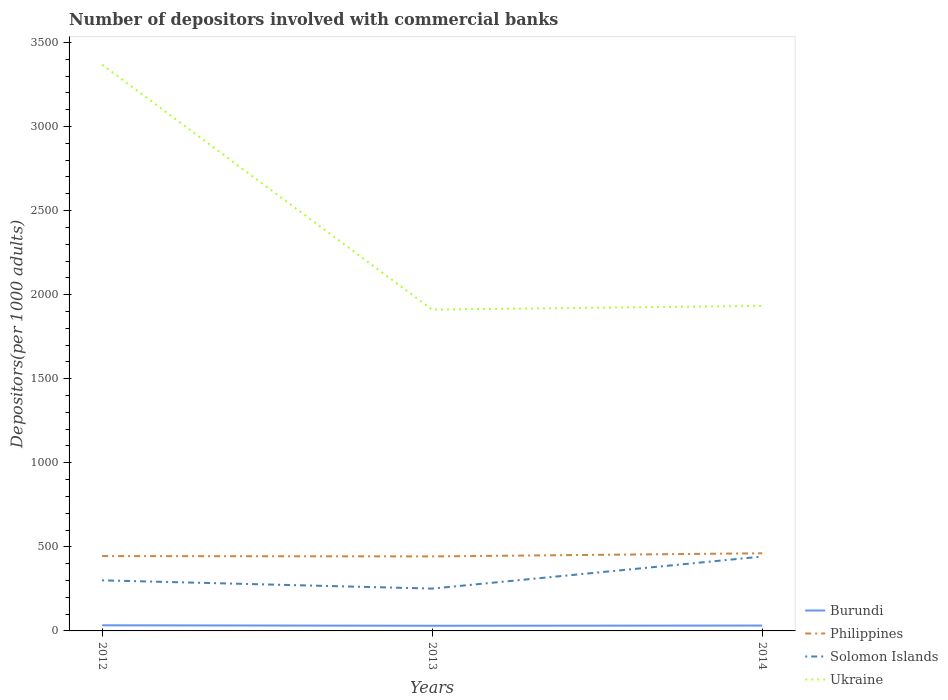Is the number of lines equal to the number of legend labels?
Give a very brief answer. Yes. Across all years, what is the maximum number of depositors involved with commercial banks in Philippines?
Provide a succinct answer. 443.08. In which year was the number of depositors involved with commercial banks in Philippines maximum?
Offer a terse response. 2013. What is the total number of depositors involved with commercial banks in Philippines in the graph?
Offer a terse response. -18.8. What is the difference between the highest and the second highest number of depositors involved with commercial banks in Burundi?
Offer a terse response. 2.74. What is the difference between the highest and the lowest number of depositors involved with commercial banks in Ukraine?
Your answer should be very brief. 1. Is the number of depositors involved with commercial banks in Ukraine strictly greater than the number of depositors involved with commercial banks in Solomon Islands over the years?
Ensure brevity in your answer.  No. Where does the legend appear in the graph?
Your response must be concise. Bottom right. What is the title of the graph?
Ensure brevity in your answer.  Number of depositors involved with commercial banks. Does "Other small states" appear as one of the legend labels in the graph?
Your response must be concise. No. What is the label or title of the Y-axis?
Give a very brief answer. Depositors(per 1000 adults). What is the Depositors(per 1000 adults) of Burundi in 2012?
Your response must be concise. 33.49. What is the Depositors(per 1000 adults) of Philippines in 2012?
Ensure brevity in your answer.  445.28. What is the Depositors(per 1000 adults) of Solomon Islands in 2012?
Your answer should be very brief. 300.87. What is the Depositors(per 1000 adults) in Ukraine in 2012?
Provide a succinct answer. 3368.39. What is the Depositors(per 1000 adults) in Burundi in 2013?
Your answer should be very brief. 30.75. What is the Depositors(per 1000 adults) of Philippines in 2013?
Give a very brief answer. 443.08. What is the Depositors(per 1000 adults) of Solomon Islands in 2013?
Offer a very short reply. 251.79. What is the Depositors(per 1000 adults) in Ukraine in 2013?
Give a very brief answer. 1911.24. What is the Depositors(per 1000 adults) in Burundi in 2014?
Your response must be concise. 31.96. What is the Depositors(per 1000 adults) in Philippines in 2014?
Your answer should be very brief. 461.88. What is the Depositors(per 1000 adults) in Solomon Islands in 2014?
Give a very brief answer. 442.39. What is the Depositors(per 1000 adults) in Ukraine in 2014?
Provide a short and direct response. 1933.56. Across all years, what is the maximum Depositors(per 1000 adults) in Burundi?
Give a very brief answer. 33.49. Across all years, what is the maximum Depositors(per 1000 adults) of Philippines?
Offer a very short reply. 461.88. Across all years, what is the maximum Depositors(per 1000 adults) of Solomon Islands?
Provide a succinct answer. 442.39. Across all years, what is the maximum Depositors(per 1000 adults) in Ukraine?
Offer a very short reply. 3368.39. Across all years, what is the minimum Depositors(per 1000 adults) of Burundi?
Your answer should be very brief. 30.75. Across all years, what is the minimum Depositors(per 1000 adults) of Philippines?
Your response must be concise. 443.08. Across all years, what is the minimum Depositors(per 1000 adults) of Solomon Islands?
Provide a succinct answer. 251.79. Across all years, what is the minimum Depositors(per 1000 adults) in Ukraine?
Give a very brief answer. 1911.24. What is the total Depositors(per 1000 adults) of Burundi in the graph?
Offer a very short reply. 96.2. What is the total Depositors(per 1000 adults) of Philippines in the graph?
Offer a terse response. 1350.24. What is the total Depositors(per 1000 adults) in Solomon Islands in the graph?
Your answer should be compact. 995.05. What is the total Depositors(per 1000 adults) in Ukraine in the graph?
Make the answer very short. 7213.18. What is the difference between the Depositors(per 1000 adults) in Burundi in 2012 and that in 2013?
Your answer should be very brief. 2.74. What is the difference between the Depositors(per 1000 adults) of Philippines in 2012 and that in 2013?
Provide a succinct answer. 2.2. What is the difference between the Depositors(per 1000 adults) of Solomon Islands in 2012 and that in 2013?
Your answer should be compact. 49.08. What is the difference between the Depositors(per 1000 adults) in Ukraine in 2012 and that in 2013?
Make the answer very short. 1457.15. What is the difference between the Depositors(per 1000 adults) of Burundi in 2012 and that in 2014?
Your answer should be very brief. 1.53. What is the difference between the Depositors(per 1000 adults) of Philippines in 2012 and that in 2014?
Provide a short and direct response. -16.6. What is the difference between the Depositors(per 1000 adults) of Solomon Islands in 2012 and that in 2014?
Make the answer very short. -141.52. What is the difference between the Depositors(per 1000 adults) of Ukraine in 2012 and that in 2014?
Provide a succinct answer. 1434.83. What is the difference between the Depositors(per 1000 adults) in Burundi in 2013 and that in 2014?
Your response must be concise. -1.21. What is the difference between the Depositors(per 1000 adults) in Philippines in 2013 and that in 2014?
Your response must be concise. -18.8. What is the difference between the Depositors(per 1000 adults) in Solomon Islands in 2013 and that in 2014?
Offer a terse response. -190.6. What is the difference between the Depositors(per 1000 adults) of Ukraine in 2013 and that in 2014?
Your answer should be compact. -22.32. What is the difference between the Depositors(per 1000 adults) in Burundi in 2012 and the Depositors(per 1000 adults) in Philippines in 2013?
Offer a terse response. -409.59. What is the difference between the Depositors(per 1000 adults) in Burundi in 2012 and the Depositors(per 1000 adults) in Solomon Islands in 2013?
Make the answer very short. -218.3. What is the difference between the Depositors(per 1000 adults) in Burundi in 2012 and the Depositors(per 1000 adults) in Ukraine in 2013?
Your answer should be compact. -1877.75. What is the difference between the Depositors(per 1000 adults) in Philippines in 2012 and the Depositors(per 1000 adults) in Solomon Islands in 2013?
Provide a succinct answer. 193.49. What is the difference between the Depositors(per 1000 adults) of Philippines in 2012 and the Depositors(per 1000 adults) of Ukraine in 2013?
Your answer should be compact. -1465.96. What is the difference between the Depositors(per 1000 adults) in Solomon Islands in 2012 and the Depositors(per 1000 adults) in Ukraine in 2013?
Your answer should be very brief. -1610.36. What is the difference between the Depositors(per 1000 adults) in Burundi in 2012 and the Depositors(per 1000 adults) in Philippines in 2014?
Make the answer very short. -428.39. What is the difference between the Depositors(per 1000 adults) in Burundi in 2012 and the Depositors(per 1000 adults) in Solomon Islands in 2014?
Offer a terse response. -408.9. What is the difference between the Depositors(per 1000 adults) in Burundi in 2012 and the Depositors(per 1000 adults) in Ukraine in 2014?
Provide a succinct answer. -1900.07. What is the difference between the Depositors(per 1000 adults) of Philippines in 2012 and the Depositors(per 1000 adults) of Solomon Islands in 2014?
Your answer should be compact. 2.89. What is the difference between the Depositors(per 1000 adults) in Philippines in 2012 and the Depositors(per 1000 adults) in Ukraine in 2014?
Keep it short and to the point. -1488.28. What is the difference between the Depositors(per 1000 adults) of Solomon Islands in 2012 and the Depositors(per 1000 adults) of Ukraine in 2014?
Give a very brief answer. -1632.68. What is the difference between the Depositors(per 1000 adults) of Burundi in 2013 and the Depositors(per 1000 adults) of Philippines in 2014?
Offer a terse response. -431.13. What is the difference between the Depositors(per 1000 adults) in Burundi in 2013 and the Depositors(per 1000 adults) in Solomon Islands in 2014?
Give a very brief answer. -411.64. What is the difference between the Depositors(per 1000 adults) of Burundi in 2013 and the Depositors(per 1000 adults) of Ukraine in 2014?
Keep it short and to the point. -1902.81. What is the difference between the Depositors(per 1000 adults) in Philippines in 2013 and the Depositors(per 1000 adults) in Solomon Islands in 2014?
Provide a short and direct response. 0.69. What is the difference between the Depositors(per 1000 adults) of Philippines in 2013 and the Depositors(per 1000 adults) of Ukraine in 2014?
Provide a succinct answer. -1490.48. What is the difference between the Depositors(per 1000 adults) of Solomon Islands in 2013 and the Depositors(per 1000 adults) of Ukraine in 2014?
Give a very brief answer. -1681.77. What is the average Depositors(per 1000 adults) in Burundi per year?
Ensure brevity in your answer.  32.07. What is the average Depositors(per 1000 adults) in Philippines per year?
Your answer should be very brief. 450.08. What is the average Depositors(per 1000 adults) in Solomon Islands per year?
Your response must be concise. 331.68. What is the average Depositors(per 1000 adults) in Ukraine per year?
Keep it short and to the point. 2404.39. In the year 2012, what is the difference between the Depositors(per 1000 adults) in Burundi and Depositors(per 1000 adults) in Philippines?
Keep it short and to the point. -411.79. In the year 2012, what is the difference between the Depositors(per 1000 adults) of Burundi and Depositors(per 1000 adults) of Solomon Islands?
Offer a terse response. -267.39. In the year 2012, what is the difference between the Depositors(per 1000 adults) in Burundi and Depositors(per 1000 adults) in Ukraine?
Keep it short and to the point. -3334.9. In the year 2012, what is the difference between the Depositors(per 1000 adults) of Philippines and Depositors(per 1000 adults) of Solomon Islands?
Give a very brief answer. 144.41. In the year 2012, what is the difference between the Depositors(per 1000 adults) of Philippines and Depositors(per 1000 adults) of Ukraine?
Your answer should be very brief. -2923.11. In the year 2012, what is the difference between the Depositors(per 1000 adults) of Solomon Islands and Depositors(per 1000 adults) of Ukraine?
Ensure brevity in your answer.  -3067.51. In the year 2013, what is the difference between the Depositors(per 1000 adults) of Burundi and Depositors(per 1000 adults) of Philippines?
Keep it short and to the point. -412.33. In the year 2013, what is the difference between the Depositors(per 1000 adults) in Burundi and Depositors(per 1000 adults) in Solomon Islands?
Keep it short and to the point. -221.04. In the year 2013, what is the difference between the Depositors(per 1000 adults) in Burundi and Depositors(per 1000 adults) in Ukraine?
Your answer should be very brief. -1880.49. In the year 2013, what is the difference between the Depositors(per 1000 adults) in Philippines and Depositors(per 1000 adults) in Solomon Islands?
Offer a terse response. 191.29. In the year 2013, what is the difference between the Depositors(per 1000 adults) in Philippines and Depositors(per 1000 adults) in Ukraine?
Make the answer very short. -1468.15. In the year 2013, what is the difference between the Depositors(per 1000 adults) of Solomon Islands and Depositors(per 1000 adults) of Ukraine?
Give a very brief answer. -1659.45. In the year 2014, what is the difference between the Depositors(per 1000 adults) of Burundi and Depositors(per 1000 adults) of Philippines?
Provide a succinct answer. -429.92. In the year 2014, what is the difference between the Depositors(per 1000 adults) in Burundi and Depositors(per 1000 adults) in Solomon Islands?
Give a very brief answer. -410.43. In the year 2014, what is the difference between the Depositors(per 1000 adults) in Burundi and Depositors(per 1000 adults) in Ukraine?
Your answer should be very brief. -1901.6. In the year 2014, what is the difference between the Depositors(per 1000 adults) in Philippines and Depositors(per 1000 adults) in Solomon Islands?
Your answer should be very brief. 19.49. In the year 2014, what is the difference between the Depositors(per 1000 adults) of Philippines and Depositors(per 1000 adults) of Ukraine?
Make the answer very short. -1471.68. In the year 2014, what is the difference between the Depositors(per 1000 adults) in Solomon Islands and Depositors(per 1000 adults) in Ukraine?
Ensure brevity in your answer.  -1491.17. What is the ratio of the Depositors(per 1000 adults) of Burundi in 2012 to that in 2013?
Keep it short and to the point. 1.09. What is the ratio of the Depositors(per 1000 adults) of Solomon Islands in 2012 to that in 2013?
Ensure brevity in your answer.  1.19. What is the ratio of the Depositors(per 1000 adults) of Ukraine in 2012 to that in 2013?
Offer a terse response. 1.76. What is the ratio of the Depositors(per 1000 adults) in Burundi in 2012 to that in 2014?
Your response must be concise. 1.05. What is the ratio of the Depositors(per 1000 adults) in Philippines in 2012 to that in 2014?
Keep it short and to the point. 0.96. What is the ratio of the Depositors(per 1000 adults) of Solomon Islands in 2012 to that in 2014?
Your answer should be very brief. 0.68. What is the ratio of the Depositors(per 1000 adults) of Ukraine in 2012 to that in 2014?
Keep it short and to the point. 1.74. What is the ratio of the Depositors(per 1000 adults) in Burundi in 2013 to that in 2014?
Ensure brevity in your answer.  0.96. What is the ratio of the Depositors(per 1000 adults) in Philippines in 2013 to that in 2014?
Keep it short and to the point. 0.96. What is the ratio of the Depositors(per 1000 adults) of Solomon Islands in 2013 to that in 2014?
Give a very brief answer. 0.57. What is the ratio of the Depositors(per 1000 adults) of Ukraine in 2013 to that in 2014?
Your answer should be very brief. 0.99. What is the difference between the highest and the second highest Depositors(per 1000 adults) in Burundi?
Provide a short and direct response. 1.53. What is the difference between the highest and the second highest Depositors(per 1000 adults) in Philippines?
Offer a terse response. 16.6. What is the difference between the highest and the second highest Depositors(per 1000 adults) of Solomon Islands?
Offer a very short reply. 141.52. What is the difference between the highest and the second highest Depositors(per 1000 adults) of Ukraine?
Make the answer very short. 1434.83. What is the difference between the highest and the lowest Depositors(per 1000 adults) of Burundi?
Provide a succinct answer. 2.74. What is the difference between the highest and the lowest Depositors(per 1000 adults) in Philippines?
Ensure brevity in your answer.  18.8. What is the difference between the highest and the lowest Depositors(per 1000 adults) in Solomon Islands?
Keep it short and to the point. 190.6. What is the difference between the highest and the lowest Depositors(per 1000 adults) of Ukraine?
Your response must be concise. 1457.15. 